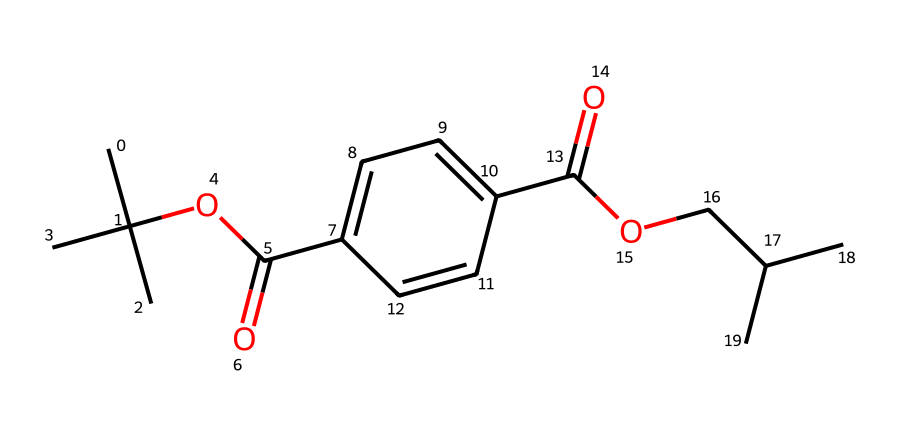What is the molecular formula of polyethylene terephthalate (PET)? The SMILES representation can be interpreted to identify the types and quantities of atoms present. By analyzing the structure, we find that there are 10 carbons (C), 10 hydrogens (H), 4 oxygens (O) forming the repeating unit of PET. Thus, the molecular formula is C10H10O4.
Answer: C10H10O4 How many oxygen atoms are in the compound? By examining the chemical structure from the SMILES representation, we can count the number of oxygen atoms present. The SMILES shows 4 instances of “O,” indicating that there are 4 oxygen atoms in total.
Answer: 4 What type of polymer is represented by this structure? The SMILES corresponds to polyethylene terephthalate, which is a type of polyester. This type of polymer is formed through the condensation reaction between diols and dicarboxylic acids. PET specifically is known for its use in fibers for textiles and plastic bottles.
Answer: polyester What functional groups are present in this molecule? Looking at the SMILES representation, we can identify several functional groups. The presence of "C(=O)" suggests carbonyl groups characteristic of ketones or carboxylic acids, specifically indicating that we have ester groups in this polyester. Thus, the main functional groups present are ester and carboxylic acids.
Answer: ester, carboxylic acid What is the significance of this polymer in traditional Romanian textile preservation? The significance lies in PET's properties, such as its strength, resistance to stretching, and low moisture absorption, making it suitable for preserving textiles. Additionally, PET is durable and withstands degradation, which is essential in maintaining the integrity of historic fabrics over time.
Answer: preservation, durability What is the polymerization process for creating polyethylene terephthalate? The polymerization of PET involves a condensation reaction between terephthalic acid (a dicarboxylic acid) and ethylene glycol (a diol). The reaction gives off water molecules as byproducts, resulting in the formation of long polymer chains of PET.
Answer: condensation reaction 